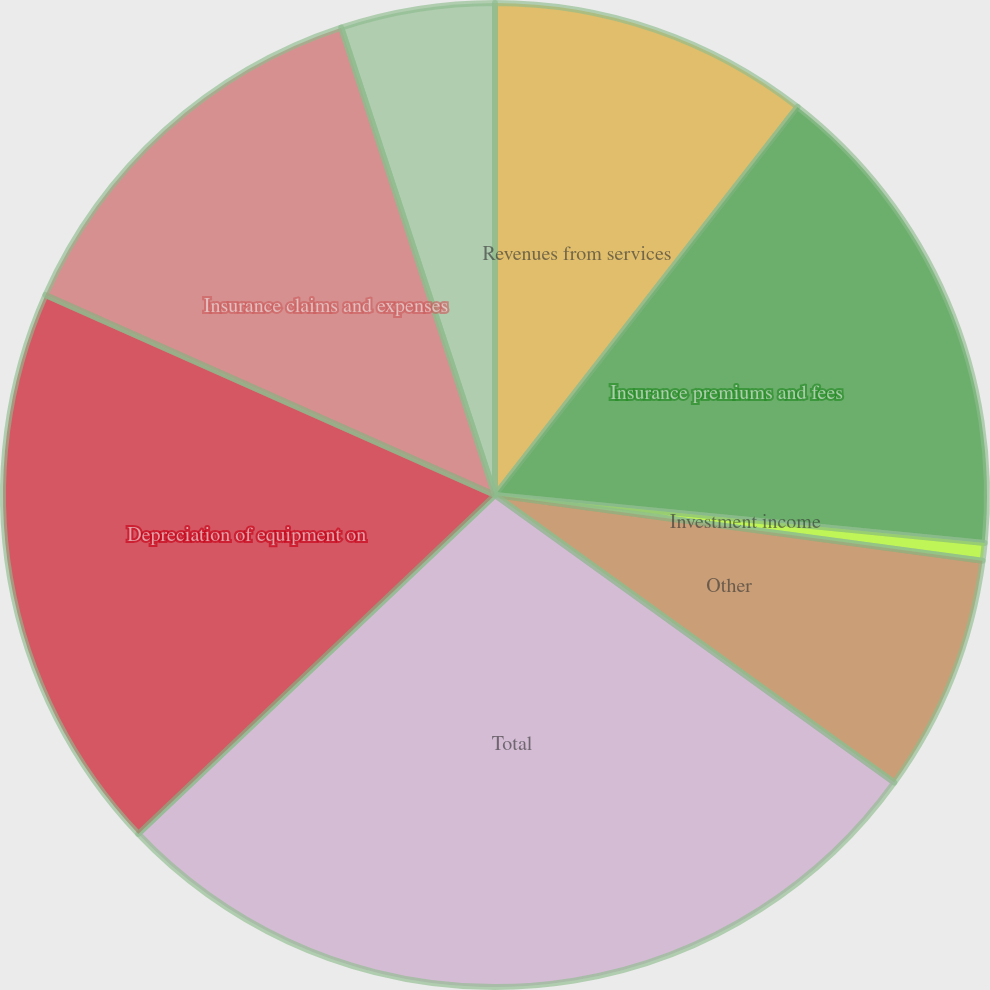<chart> <loc_0><loc_0><loc_500><loc_500><pie_chart><fcel>Revenues from services<fcel>Insurance premiums and fees<fcel>Investment income<fcel>Other<fcel>Total<fcel>Depreciation of equipment on<fcel>Insurance claims and expenses<fcel>Cost of services<nl><fcel>10.54%<fcel>16.02%<fcel>0.58%<fcel>7.8%<fcel>27.98%<fcel>18.76%<fcel>13.28%<fcel>5.06%<nl></chart> 